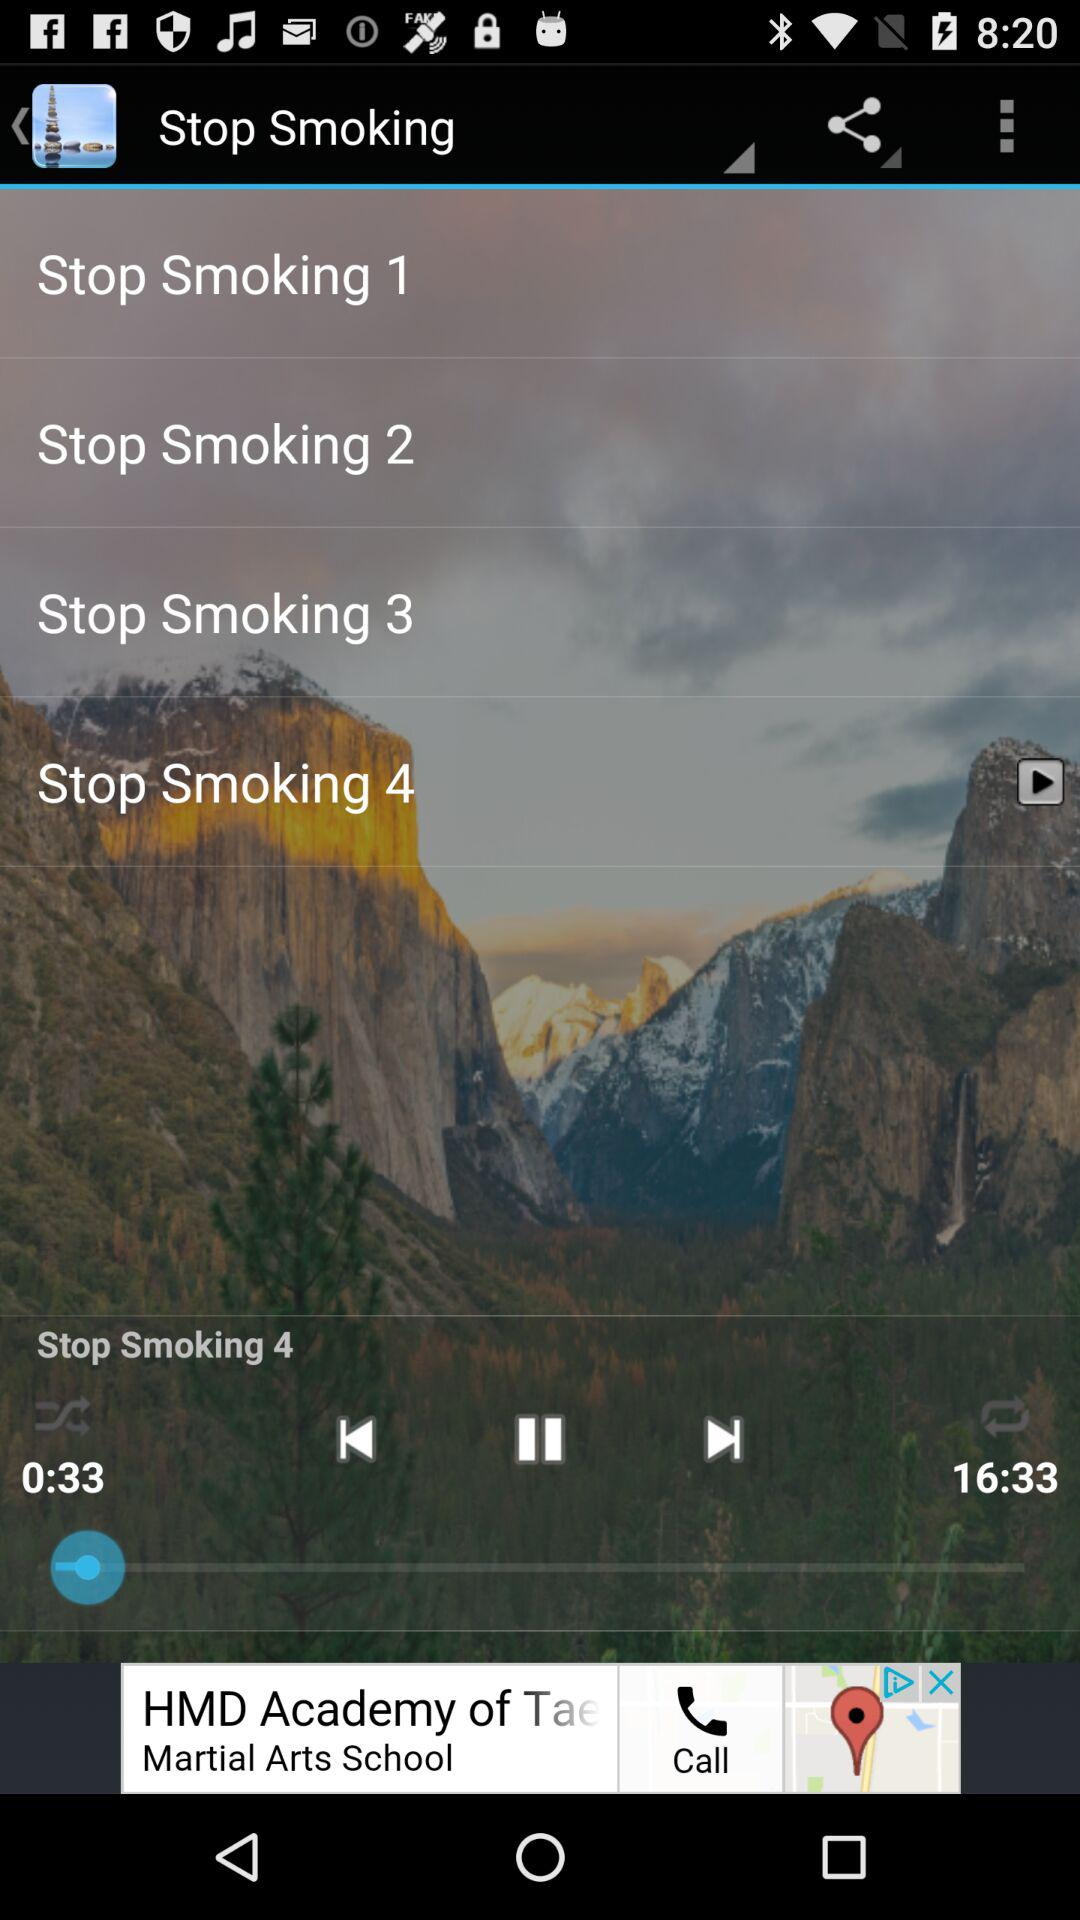For how long has the audio been played? The audio has been played for 33 seconds. 